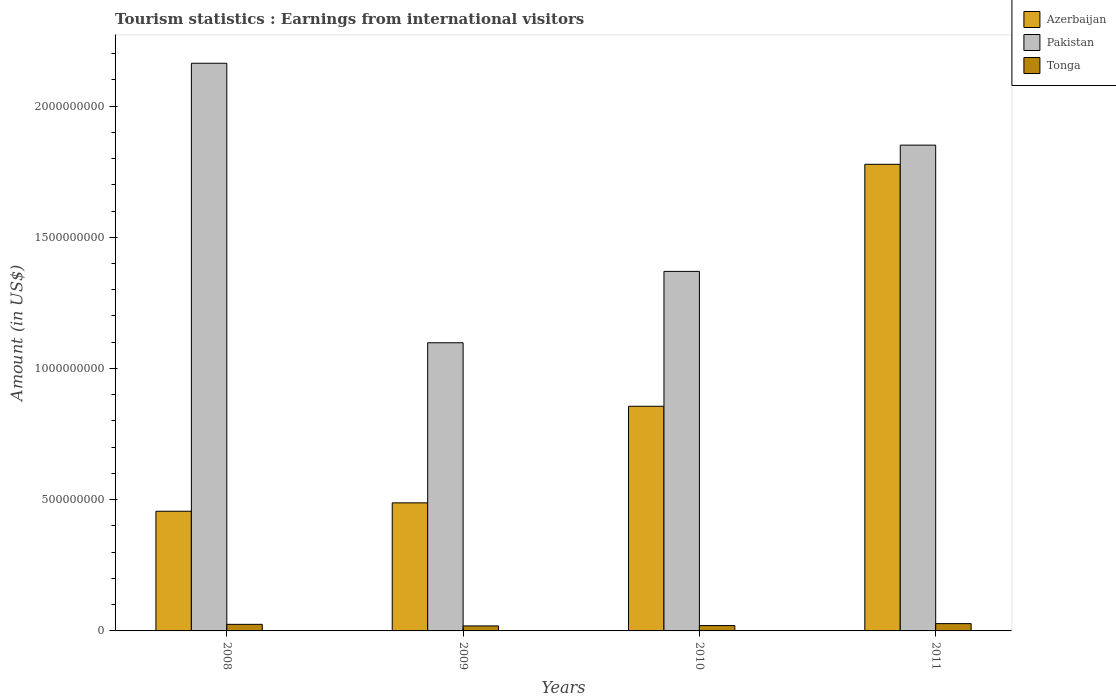How many different coloured bars are there?
Your answer should be compact. 3. How many bars are there on the 3rd tick from the left?
Offer a very short reply. 3. What is the label of the 4th group of bars from the left?
Offer a very short reply. 2011. What is the earnings from international visitors in Pakistan in 2009?
Your answer should be very brief. 1.10e+09. Across all years, what is the maximum earnings from international visitors in Azerbaijan?
Keep it short and to the point. 1.78e+09. Across all years, what is the minimum earnings from international visitors in Azerbaijan?
Your answer should be compact. 4.56e+08. In which year was the earnings from international visitors in Tonga maximum?
Offer a terse response. 2011. In which year was the earnings from international visitors in Azerbaijan minimum?
Your answer should be compact. 2008. What is the total earnings from international visitors in Pakistan in the graph?
Ensure brevity in your answer.  6.48e+09. What is the difference between the earnings from international visitors in Azerbaijan in 2009 and that in 2011?
Make the answer very short. -1.29e+09. What is the difference between the earnings from international visitors in Azerbaijan in 2008 and the earnings from international visitors in Pakistan in 2011?
Provide a succinct answer. -1.40e+09. What is the average earnings from international visitors in Pakistan per year?
Your answer should be compact. 1.62e+09. In the year 2008, what is the difference between the earnings from international visitors in Azerbaijan and earnings from international visitors in Pakistan?
Ensure brevity in your answer.  -1.71e+09. What is the ratio of the earnings from international visitors in Azerbaijan in 2009 to that in 2011?
Provide a short and direct response. 0.27. Is the earnings from international visitors in Tonga in 2010 less than that in 2011?
Your response must be concise. Yes. What is the difference between the highest and the second highest earnings from international visitors in Tonga?
Provide a short and direct response. 2.70e+06. What is the difference between the highest and the lowest earnings from international visitors in Azerbaijan?
Your answer should be compact. 1.32e+09. In how many years, is the earnings from international visitors in Azerbaijan greater than the average earnings from international visitors in Azerbaijan taken over all years?
Ensure brevity in your answer.  1. Is the sum of the earnings from international visitors in Azerbaijan in 2008 and 2010 greater than the maximum earnings from international visitors in Pakistan across all years?
Your answer should be very brief. No. What does the 1st bar from the left in 2011 represents?
Provide a succinct answer. Azerbaijan. What does the 3rd bar from the right in 2009 represents?
Your response must be concise. Azerbaijan. Is it the case that in every year, the sum of the earnings from international visitors in Azerbaijan and earnings from international visitors in Pakistan is greater than the earnings from international visitors in Tonga?
Keep it short and to the point. Yes. How many bars are there?
Offer a very short reply. 12. How many years are there in the graph?
Your answer should be compact. 4. What is the difference between two consecutive major ticks on the Y-axis?
Provide a succinct answer. 5.00e+08. Are the values on the major ticks of Y-axis written in scientific E-notation?
Provide a succinct answer. No. Does the graph contain any zero values?
Your response must be concise. No. Does the graph contain grids?
Ensure brevity in your answer.  No. How many legend labels are there?
Offer a very short reply. 3. What is the title of the graph?
Keep it short and to the point. Tourism statistics : Earnings from international visitors. What is the label or title of the Y-axis?
Provide a short and direct response. Amount (in US$). What is the Amount (in US$) in Azerbaijan in 2008?
Your response must be concise. 4.56e+08. What is the Amount (in US$) of Pakistan in 2008?
Ensure brevity in your answer.  2.16e+09. What is the Amount (in US$) of Tonga in 2008?
Offer a terse response. 2.51e+07. What is the Amount (in US$) in Azerbaijan in 2009?
Give a very brief answer. 4.88e+08. What is the Amount (in US$) in Pakistan in 2009?
Make the answer very short. 1.10e+09. What is the Amount (in US$) of Tonga in 2009?
Keep it short and to the point. 1.91e+07. What is the Amount (in US$) in Azerbaijan in 2010?
Make the answer very short. 8.56e+08. What is the Amount (in US$) of Pakistan in 2010?
Provide a short and direct response. 1.37e+09. What is the Amount (in US$) in Tonga in 2010?
Your answer should be compact. 2.04e+07. What is the Amount (in US$) of Azerbaijan in 2011?
Provide a succinct answer. 1.78e+09. What is the Amount (in US$) in Pakistan in 2011?
Your response must be concise. 1.85e+09. What is the Amount (in US$) of Tonga in 2011?
Make the answer very short. 2.78e+07. Across all years, what is the maximum Amount (in US$) of Azerbaijan?
Keep it short and to the point. 1.78e+09. Across all years, what is the maximum Amount (in US$) of Pakistan?
Your answer should be very brief. 2.16e+09. Across all years, what is the maximum Amount (in US$) of Tonga?
Your answer should be very brief. 2.78e+07. Across all years, what is the minimum Amount (in US$) of Azerbaijan?
Your response must be concise. 4.56e+08. Across all years, what is the minimum Amount (in US$) in Pakistan?
Keep it short and to the point. 1.10e+09. Across all years, what is the minimum Amount (in US$) in Tonga?
Provide a short and direct response. 1.91e+07. What is the total Amount (in US$) of Azerbaijan in the graph?
Your answer should be very brief. 3.58e+09. What is the total Amount (in US$) of Pakistan in the graph?
Give a very brief answer. 6.48e+09. What is the total Amount (in US$) of Tonga in the graph?
Provide a short and direct response. 9.24e+07. What is the difference between the Amount (in US$) of Azerbaijan in 2008 and that in 2009?
Offer a terse response. -3.20e+07. What is the difference between the Amount (in US$) of Pakistan in 2008 and that in 2009?
Your answer should be very brief. 1.06e+09. What is the difference between the Amount (in US$) of Azerbaijan in 2008 and that in 2010?
Give a very brief answer. -4.00e+08. What is the difference between the Amount (in US$) of Pakistan in 2008 and that in 2010?
Provide a short and direct response. 7.93e+08. What is the difference between the Amount (in US$) in Tonga in 2008 and that in 2010?
Keep it short and to the point. 4.70e+06. What is the difference between the Amount (in US$) of Azerbaijan in 2008 and that in 2011?
Make the answer very short. -1.32e+09. What is the difference between the Amount (in US$) in Pakistan in 2008 and that in 2011?
Provide a succinct answer. 3.12e+08. What is the difference between the Amount (in US$) of Tonga in 2008 and that in 2011?
Keep it short and to the point. -2.70e+06. What is the difference between the Amount (in US$) of Azerbaijan in 2009 and that in 2010?
Offer a terse response. -3.68e+08. What is the difference between the Amount (in US$) in Pakistan in 2009 and that in 2010?
Provide a short and direct response. -2.72e+08. What is the difference between the Amount (in US$) of Tonga in 2009 and that in 2010?
Ensure brevity in your answer.  -1.30e+06. What is the difference between the Amount (in US$) in Azerbaijan in 2009 and that in 2011?
Provide a succinct answer. -1.29e+09. What is the difference between the Amount (in US$) in Pakistan in 2009 and that in 2011?
Give a very brief answer. -7.53e+08. What is the difference between the Amount (in US$) of Tonga in 2009 and that in 2011?
Give a very brief answer. -8.70e+06. What is the difference between the Amount (in US$) in Azerbaijan in 2010 and that in 2011?
Keep it short and to the point. -9.22e+08. What is the difference between the Amount (in US$) in Pakistan in 2010 and that in 2011?
Your response must be concise. -4.81e+08. What is the difference between the Amount (in US$) of Tonga in 2010 and that in 2011?
Keep it short and to the point. -7.40e+06. What is the difference between the Amount (in US$) in Azerbaijan in 2008 and the Amount (in US$) in Pakistan in 2009?
Provide a succinct answer. -6.42e+08. What is the difference between the Amount (in US$) of Azerbaijan in 2008 and the Amount (in US$) of Tonga in 2009?
Your response must be concise. 4.37e+08. What is the difference between the Amount (in US$) of Pakistan in 2008 and the Amount (in US$) of Tonga in 2009?
Your answer should be compact. 2.14e+09. What is the difference between the Amount (in US$) of Azerbaijan in 2008 and the Amount (in US$) of Pakistan in 2010?
Provide a short and direct response. -9.14e+08. What is the difference between the Amount (in US$) of Azerbaijan in 2008 and the Amount (in US$) of Tonga in 2010?
Give a very brief answer. 4.36e+08. What is the difference between the Amount (in US$) in Pakistan in 2008 and the Amount (in US$) in Tonga in 2010?
Keep it short and to the point. 2.14e+09. What is the difference between the Amount (in US$) in Azerbaijan in 2008 and the Amount (in US$) in Pakistan in 2011?
Provide a succinct answer. -1.40e+09. What is the difference between the Amount (in US$) in Azerbaijan in 2008 and the Amount (in US$) in Tonga in 2011?
Provide a short and direct response. 4.28e+08. What is the difference between the Amount (in US$) of Pakistan in 2008 and the Amount (in US$) of Tonga in 2011?
Offer a terse response. 2.14e+09. What is the difference between the Amount (in US$) of Azerbaijan in 2009 and the Amount (in US$) of Pakistan in 2010?
Offer a terse response. -8.82e+08. What is the difference between the Amount (in US$) in Azerbaijan in 2009 and the Amount (in US$) in Tonga in 2010?
Your answer should be compact. 4.68e+08. What is the difference between the Amount (in US$) in Pakistan in 2009 and the Amount (in US$) in Tonga in 2010?
Your answer should be very brief. 1.08e+09. What is the difference between the Amount (in US$) in Azerbaijan in 2009 and the Amount (in US$) in Pakistan in 2011?
Offer a terse response. -1.36e+09. What is the difference between the Amount (in US$) in Azerbaijan in 2009 and the Amount (in US$) in Tonga in 2011?
Offer a terse response. 4.60e+08. What is the difference between the Amount (in US$) in Pakistan in 2009 and the Amount (in US$) in Tonga in 2011?
Your answer should be compact. 1.07e+09. What is the difference between the Amount (in US$) of Azerbaijan in 2010 and the Amount (in US$) of Pakistan in 2011?
Give a very brief answer. -9.95e+08. What is the difference between the Amount (in US$) in Azerbaijan in 2010 and the Amount (in US$) in Tonga in 2011?
Provide a short and direct response. 8.28e+08. What is the difference between the Amount (in US$) in Pakistan in 2010 and the Amount (in US$) in Tonga in 2011?
Ensure brevity in your answer.  1.34e+09. What is the average Amount (in US$) of Azerbaijan per year?
Provide a succinct answer. 8.94e+08. What is the average Amount (in US$) of Pakistan per year?
Your response must be concise. 1.62e+09. What is the average Amount (in US$) of Tonga per year?
Your response must be concise. 2.31e+07. In the year 2008, what is the difference between the Amount (in US$) in Azerbaijan and Amount (in US$) in Pakistan?
Keep it short and to the point. -1.71e+09. In the year 2008, what is the difference between the Amount (in US$) in Azerbaijan and Amount (in US$) in Tonga?
Your response must be concise. 4.31e+08. In the year 2008, what is the difference between the Amount (in US$) of Pakistan and Amount (in US$) of Tonga?
Your answer should be very brief. 2.14e+09. In the year 2009, what is the difference between the Amount (in US$) of Azerbaijan and Amount (in US$) of Pakistan?
Offer a terse response. -6.10e+08. In the year 2009, what is the difference between the Amount (in US$) in Azerbaijan and Amount (in US$) in Tonga?
Offer a very short reply. 4.69e+08. In the year 2009, what is the difference between the Amount (in US$) in Pakistan and Amount (in US$) in Tonga?
Keep it short and to the point. 1.08e+09. In the year 2010, what is the difference between the Amount (in US$) of Azerbaijan and Amount (in US$) of Pakistan?
Ensure brevity in your answer.  -5.14e+08. In the year 2010, what is the difference between the Amount (in US$) in Azerbaijan and Amount (in US$) in Tonga?
Keep it short and to the point. 8.36e+08. In the year 2010, what is the difference between the Amount (in US$) in Pakistan and Amount (in US$) in Tonga?
Provide a short and direct response. 1.35e+09. In the year 2011, what is the difference between the Amount (in US$) in Azerbaijan and Amount (in US$) in Pakistan?
Offer a terse response. -7.30e+07. In the year 2011, what is the difference between the Amount (in US$) of Azerbaijan and Amount (in US$) of Tonga?
Keep it short and to the point. 1.75e+09. In the year 2011, what is the difference between the Amount (in US$) of Pakistan and Amount (in US$) of Tonga?
Provide a short and direct response. 1.82e+09. What is the ratio of the Amount (in US$) of Azerbaijan in 2008 to that in 2009?
Keep it short and to the point. 0.93. What is the ratio of the Amount (in US$) of Pakistan in 2008 to that in 2009?
Ensure brevity in your answer.  1.97. What is the ratio of the Amount (in US$) of Tonga in 2008 to that in 2009?
Your response must be concise. 1.31. What is the ratio of the Amount (in US$) of Azerbaijan in 2008 to that in 2010?
Your answer should be very brief. 0.53. What is the ratio of the Amount (in US$) of Pakistan in 2008 to that in 2010?
Your response must be concise. 1.58. What is the ratio of the Amount (in US$) of Tonga in 2008 to that in 2010?
Give a very brief answer. 1.23. What is the ratio of the Amount (in US$) of Azerbaijan in 2008 to that in 2011?
Your answer should be compact. 0.26. What is the ratio of the Amount (in US$) in Pakistan in 2008 to that in 2011?
Give a very brief answer. 1.17. What is the ratio of the Amount (in US$) of Tonga in 2008 to that in 2011?
Your answer should be compact. 0.9. What is the ratio of the Amount (in US$) in Azerbaijan in 2009 to that in 2010?
Your answer should be very brief. 0.57. What is the ratio of the Amount (in US$) in Pakistan in 2009 to that in 2010?
Offer a terse response. 0.8. What is the ratio of the Amount (in US$) in Tonga in 2009 to that in 2010?
Ensure brevity in your answer.  0.94. What is the ratio of the Amount (in US$) in Azerbaijan in 2009 to that in 2011?
Give a very brief answer. 0.27. What is the ratio of the Amount (in US$) of Pakistan in 2009 to that in 2011?
Your answer should be very brief. 0.59. What is the ratio of the Amount (in US$) of Tonga in 2009 to that in 2011?
Give a very brief answer. 0.69. What is the ratio of the Amount (in US$) of Azerbaijan in 2010 to that in 2011?
Make the answer very short. 0.48. What is the ratio of the Amount (in US$) in Pakistan in 2010 to that in 2011?
Offer a very short reply. 0.74. What is the ratio of the Amount (in US$) of Tonga in 2010 to that in 2011?
Your response must be concise. 0.73. What is the difference between the highest and the second highest Amount (in US$) of Azerbaijan?
Ensure brevity in your answer.  9.22e+08. What is the difference between the highest and the second highest Amount (in US$) of Pakistan?
Offer a terse response. 3.12e+08. What is the difference between the highest and the second highest Amount (in US$) of Tonga?
Make the answer very short. 2.70e+06. What is the difference between the highest and the lowest Amount (in US$) in Azerbaijan?
Offer a terse response. 1.32e+09. What is the difference between the highest and the lowest Amount (in US$) of Pakistan?
Provide a short and direct response. 1.06e+09. What is the difference between the highest and the lowest Amount (in US$) in Tonga?
Make the answer very short. 8.70e+06. 